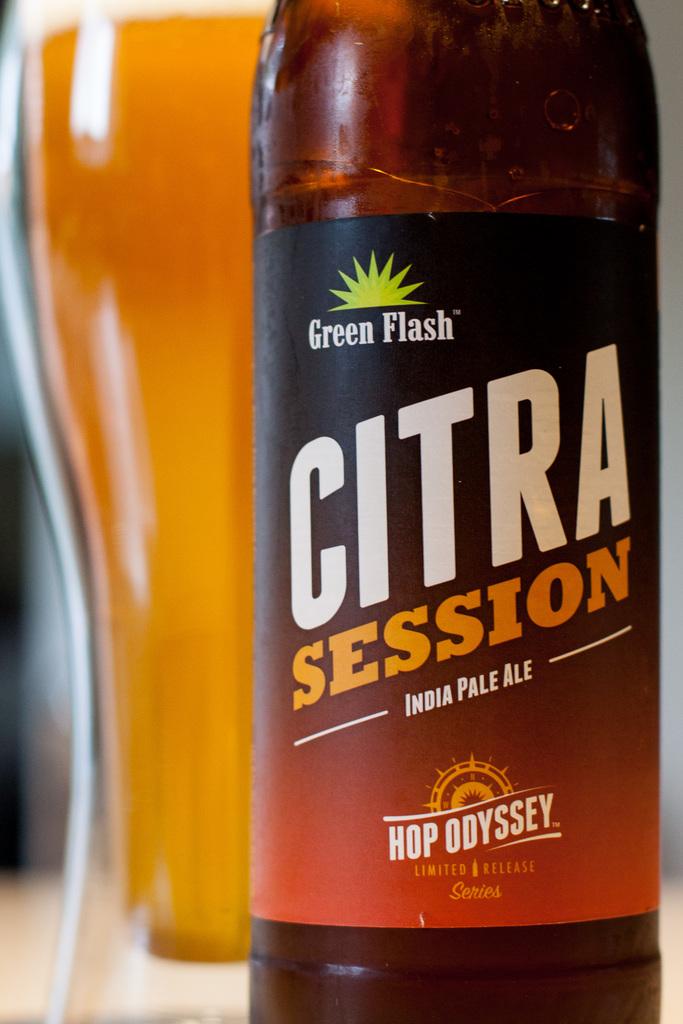What variety of beer is this?
Your answer should be compact. India pale ale. 